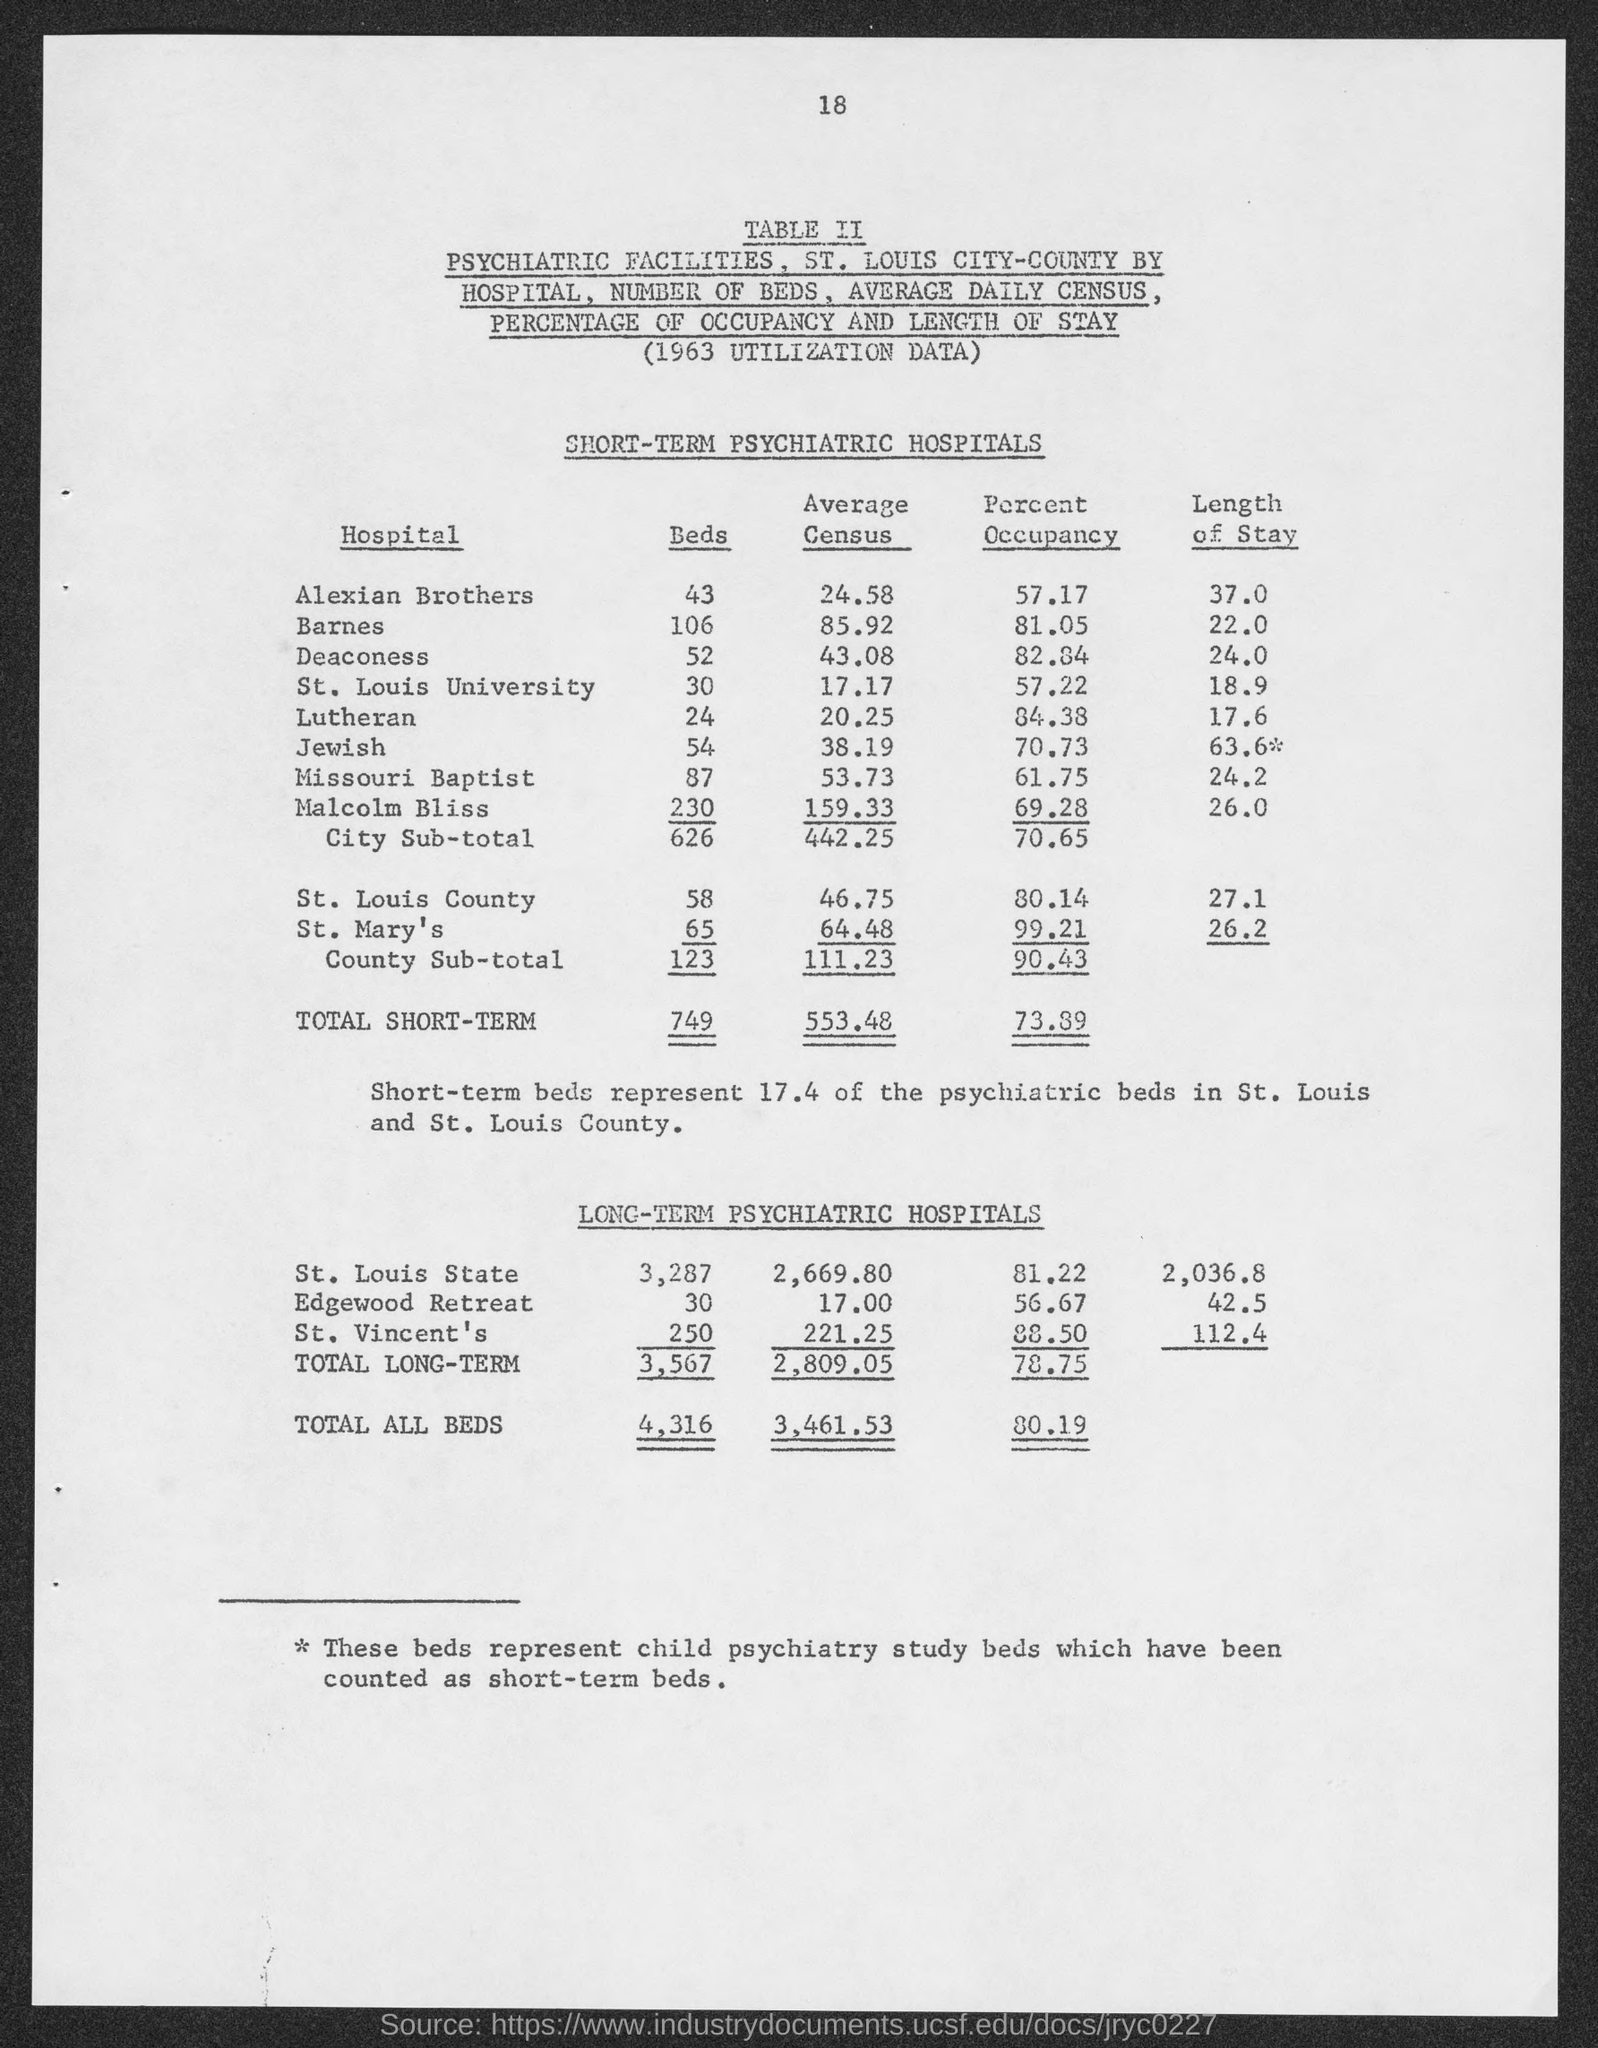What is the title of the top-table?
Your answer should be very brief. Short-term Psychiatric Hospitals. How many number of beds are there in alexian brothers hospital?
Your answer should be very brief. 43. How many number of beds are there in barnes hospital?
Keep it short and to the point. 106. How many number of beds are there in deaconess hospital?
Give a very brief answer. 52. What is the total number of beds in short- term?
Your response must be concise. 749. What percentage of beds does short-term beds represent in st. louis and st. county?
Give a very brief answer. 17.4. What is the total number of beds in long-term?
Ensure brevity in your answer.  3,567. What is total of all beds?
Keep it short and to the point. 4,316. What is the average census of alexian brothers hospital?
Ensure brevity in your answer.  24.58. What is the average census of barnes hospital?
Give a very brief answer. 85.92. 